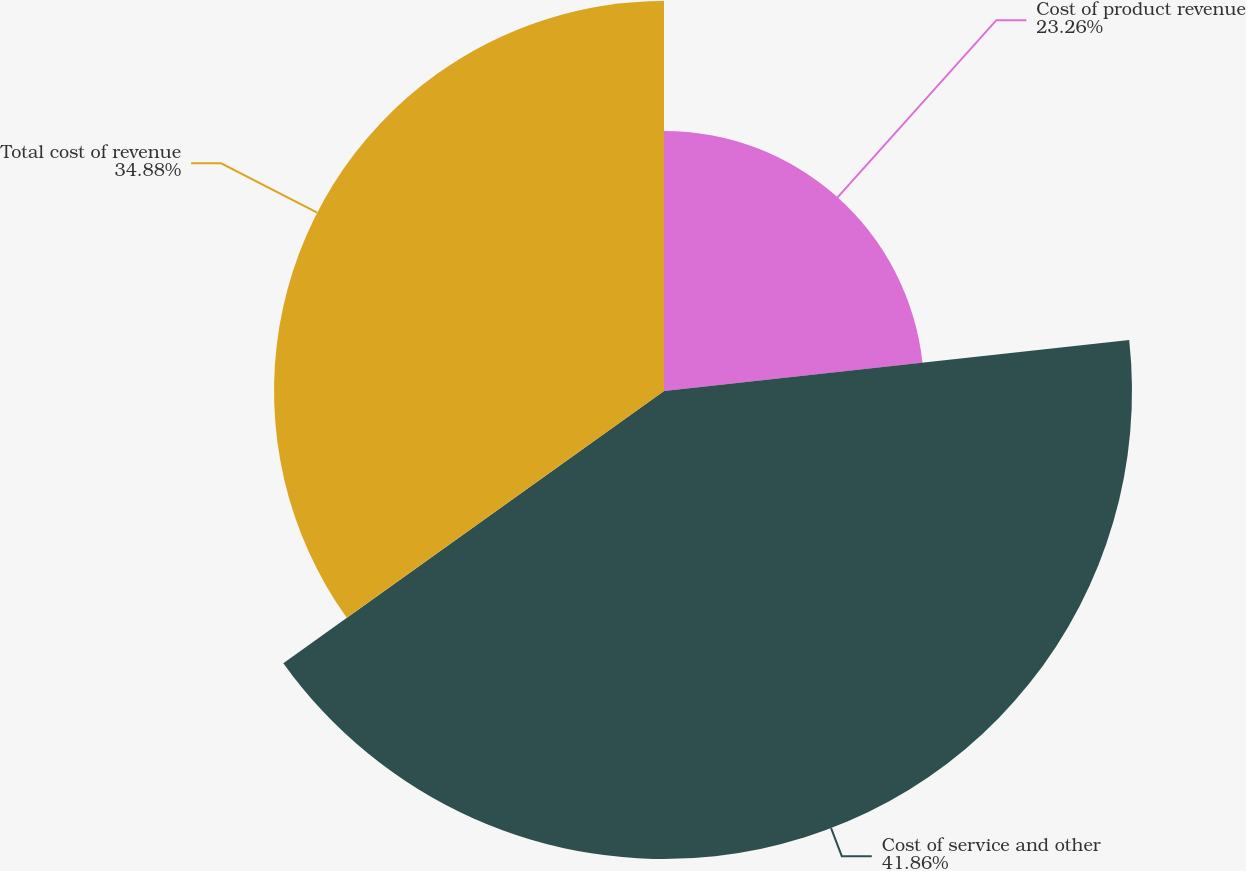<chart> <loc_0><loc_0><loc_500><loc_500><pie_chart><fcel>Cost of product revenue<fcel>Cost of service and other<fcel>Total cost of revenue<nl><fcel>23.26%<fcel>41.86%<fcel>34.88%<nl></chart> 